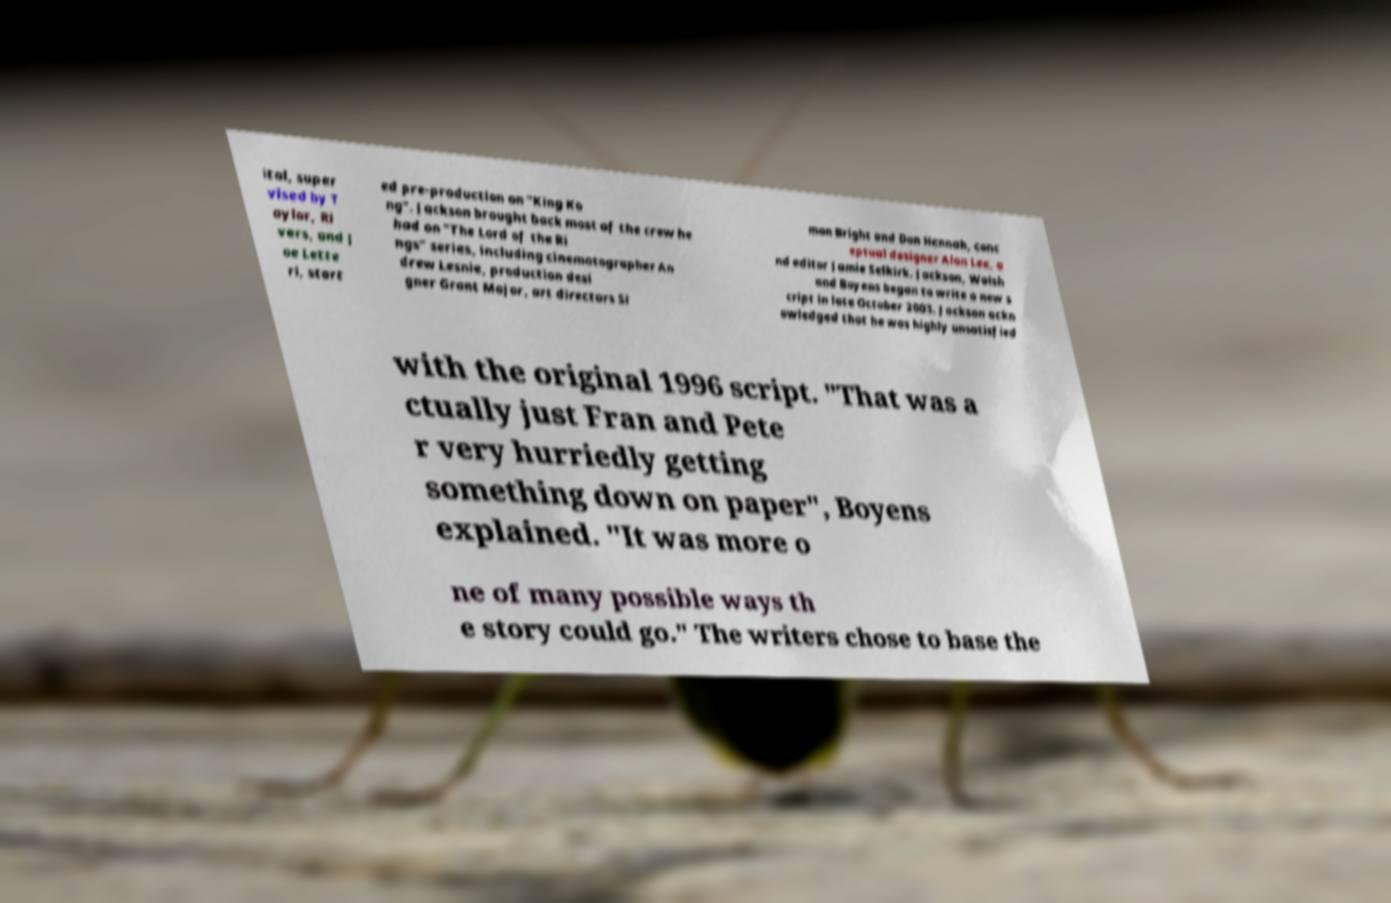Please read and relay the text visible in this image. What does it say? ital, super vised by T aylor, Ri vers, and J oe Lette ri, start ed pre-production on "King Ko ng". Jackson brought back most of the crew he had on "The Lord of the Ri ngs" series, including cinematographer An drew Lesnie, production desi gner Grant Major, art directors Si mon Bright and Dan Hennah, conc eptual designer Alan Lee, a nd editor Jamie Selkirk. Jackson, Walsh and Boyens began to write a new s cript in late October 2003. Jackson ackn owledged that he was highly unsatisfied with the original 1996 script. "That was a ctually just Fran and Pete r very hurriedly getting something down on paper", Boyens explained. "It was more o ne of many possible ways th e story could go." The writers chose to base the 